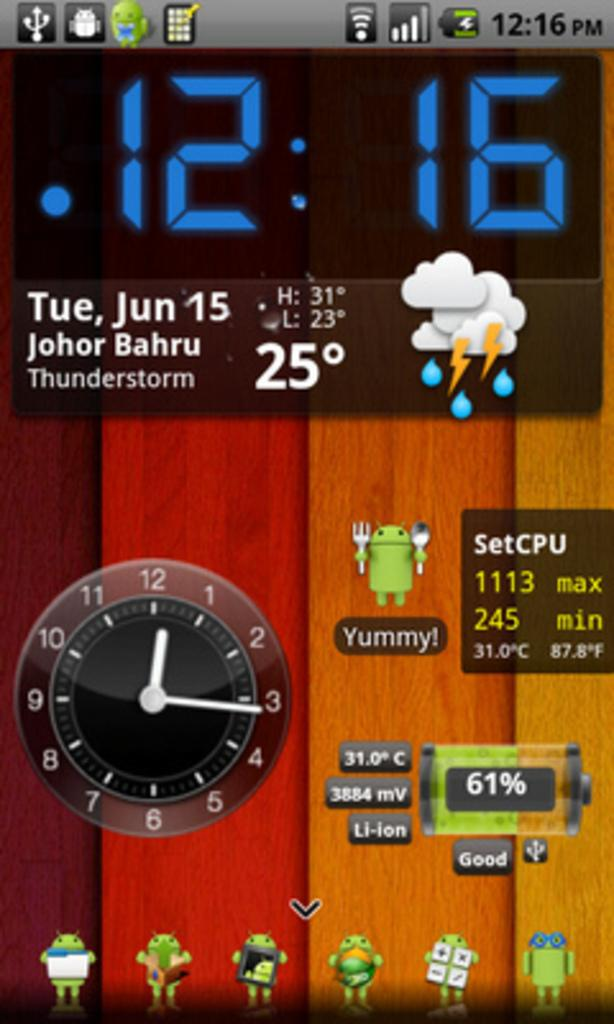What is the main subject of the picture? The main subject of the picture is a screenshot. What can be seen within the screenshot? There are icons, a digital display of time, a clock, and text visible in the screenshot. What type of celery is being used to butter the voyage in the image? There is no celery, butter, or voyage present in the image; it features a screenshot with various elements. 